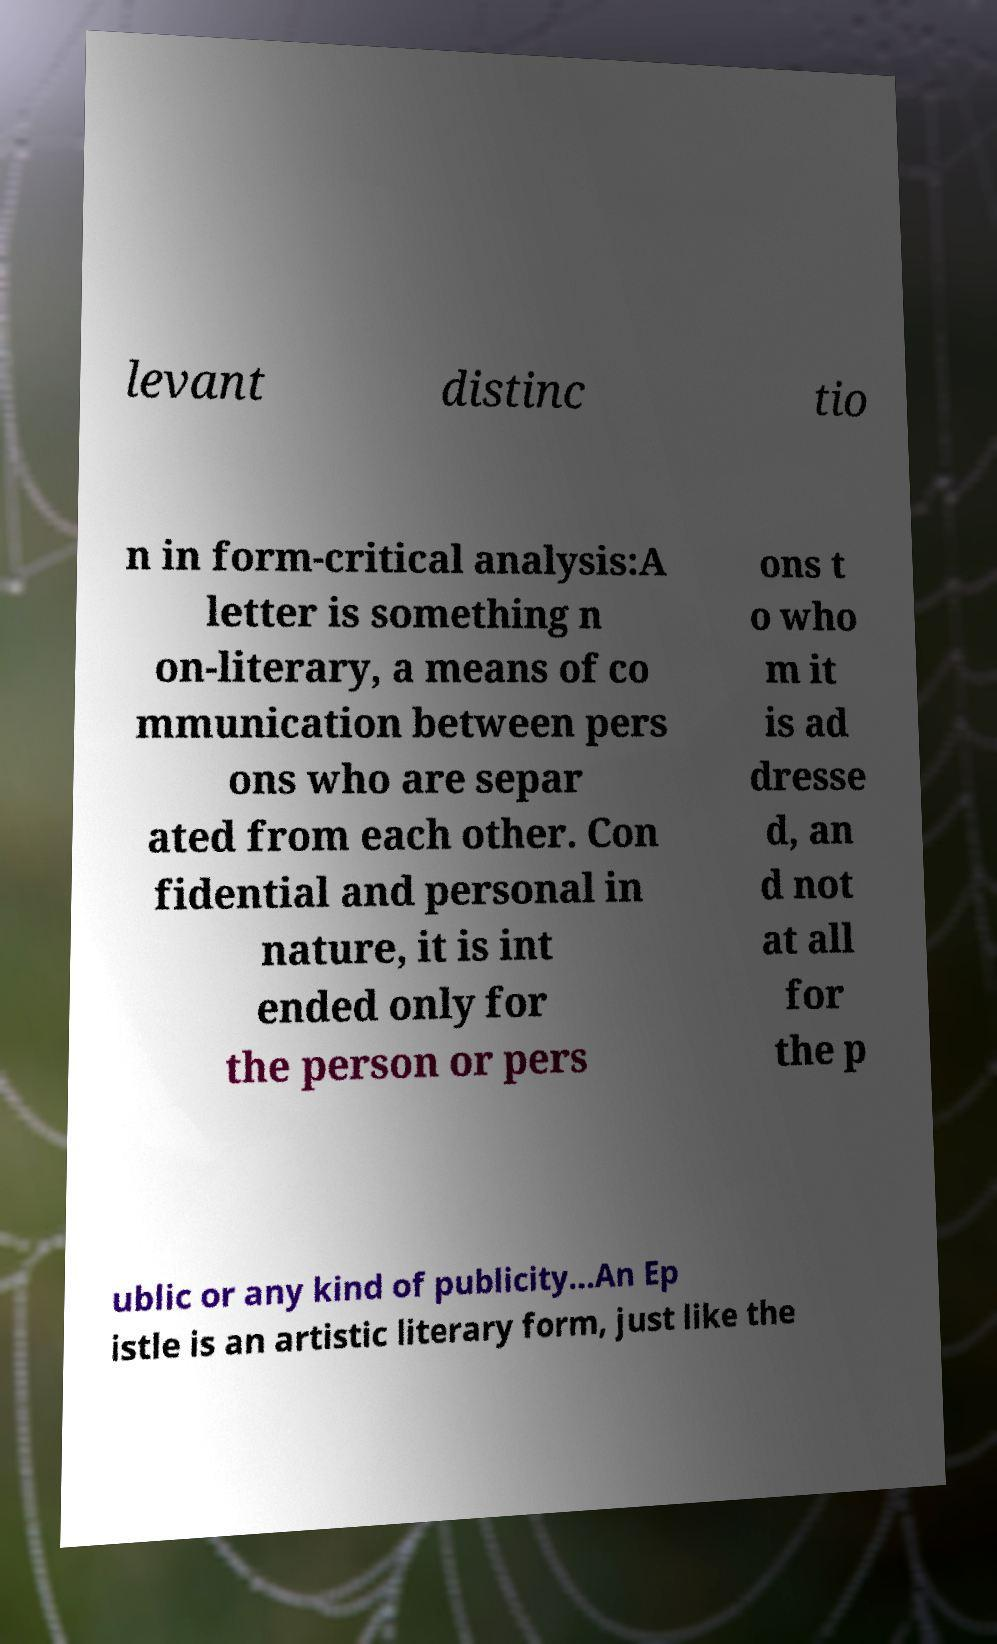What messages or text are displayed in this image? I need them in a readable, typed format. levant distinc tio n in form-critical analysis:A letter is something n on-literary, a means of co mmunication between pers ons who are separ ated from each other. Con fidential and personal in nature, it is int ended only for the person or pers ons t o who m it is ad dresse d, an d not at all for the p ublic or any kind of publicity...An Ep istle is an artistic literary form, just like the 